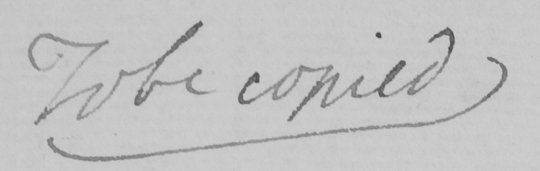What is written in this line of handwriting? To be copied 